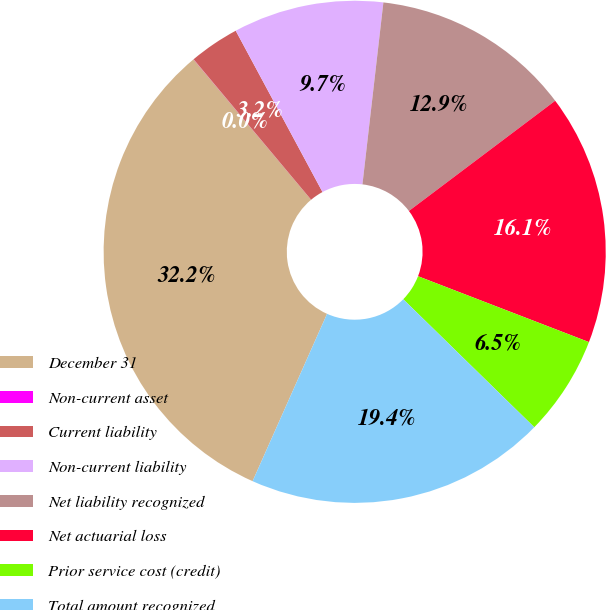Convert chart. <chart><loc_0><loc_0><loc_500><loc_500><pie_chart><fcel>December 31<fcel>Non-current asset<fcel>Current liability<fcel>Non-current liability<fcel>Net liability recognized<fcel>Net actuarial loss<fcel>Prior service cost (credit)<fcel>Total amount recognized<nl><fcel>32.24%<fcel>0.01%<fcel>3.23%<fcel>9.68%<fcel>12.9%<fcel>16.13%<fcel>6.46%<fcel>19.35%<nl></chart> 